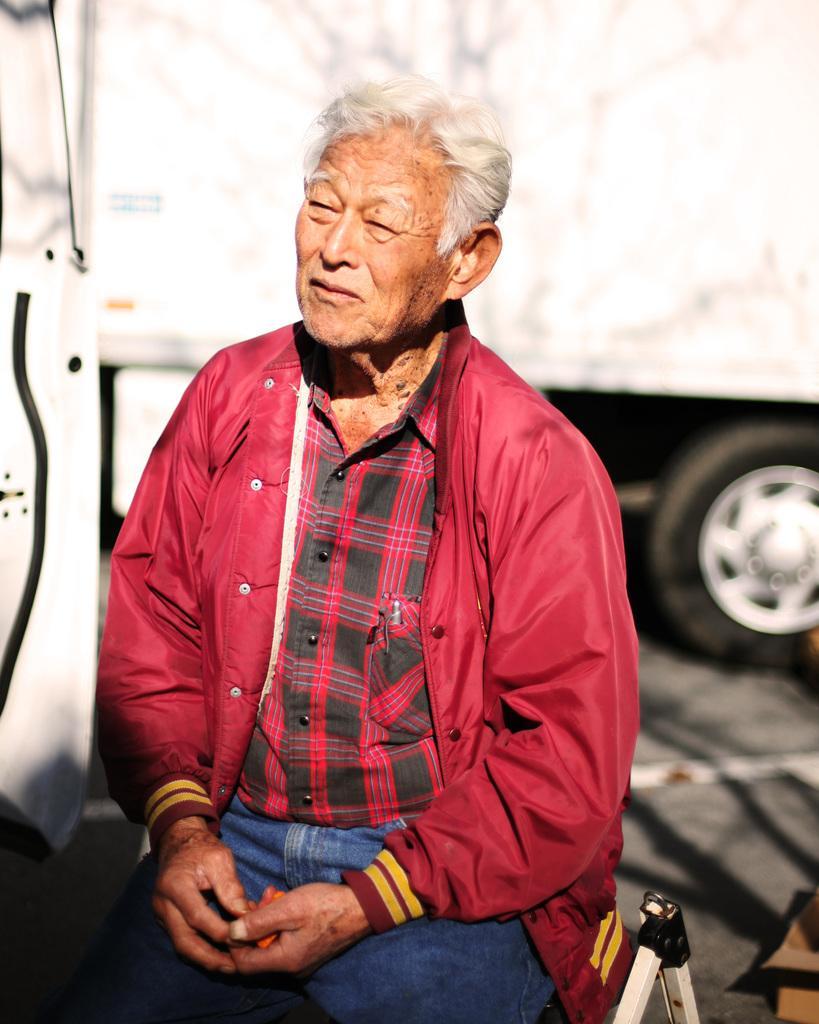How would you summarize this image in a sentence or two? In this image we can see a man. In the back there is a vehicle. 